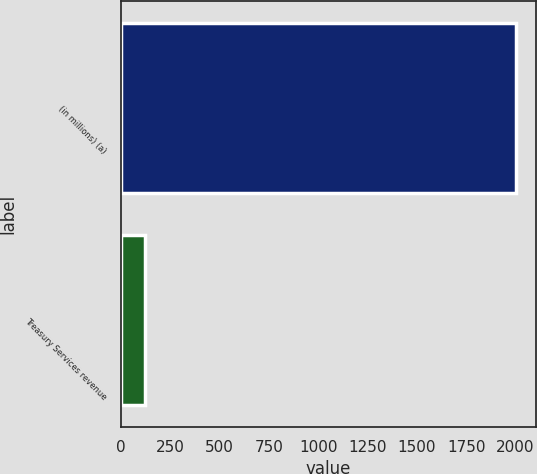<chart> <loc_0><loc_0><loc_500><loc_500><bar_chart><fcel>(in millions) (a)<fcel>Treasury Services revenue<nl><fcel>2003<fcel>118<nl></chart> 